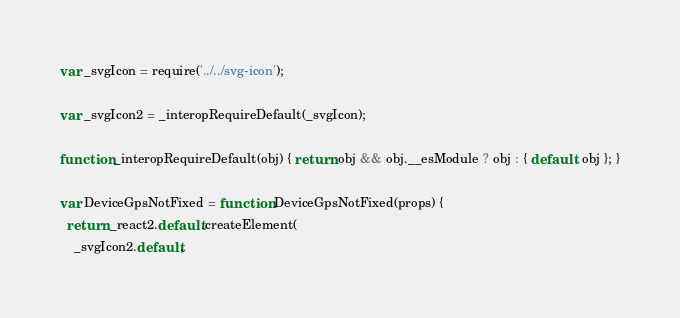<code> <loc_0><loc_0><loc_500><loc_500><_JavaScript_>
var _svgIcon = require('../../svg-icon');

var _svgIcon2 = _interopRequireDefault(_svgIcon);

function _interopRequireDefault(obj) { return obj && obj.__esModule ? obj : { default: obj }; }

var DeviceGpsNotFixed = function DeviceGpsNotFixed(props) {
  return _react2.default.createElement(
    _svgIcon2.default,</code> 